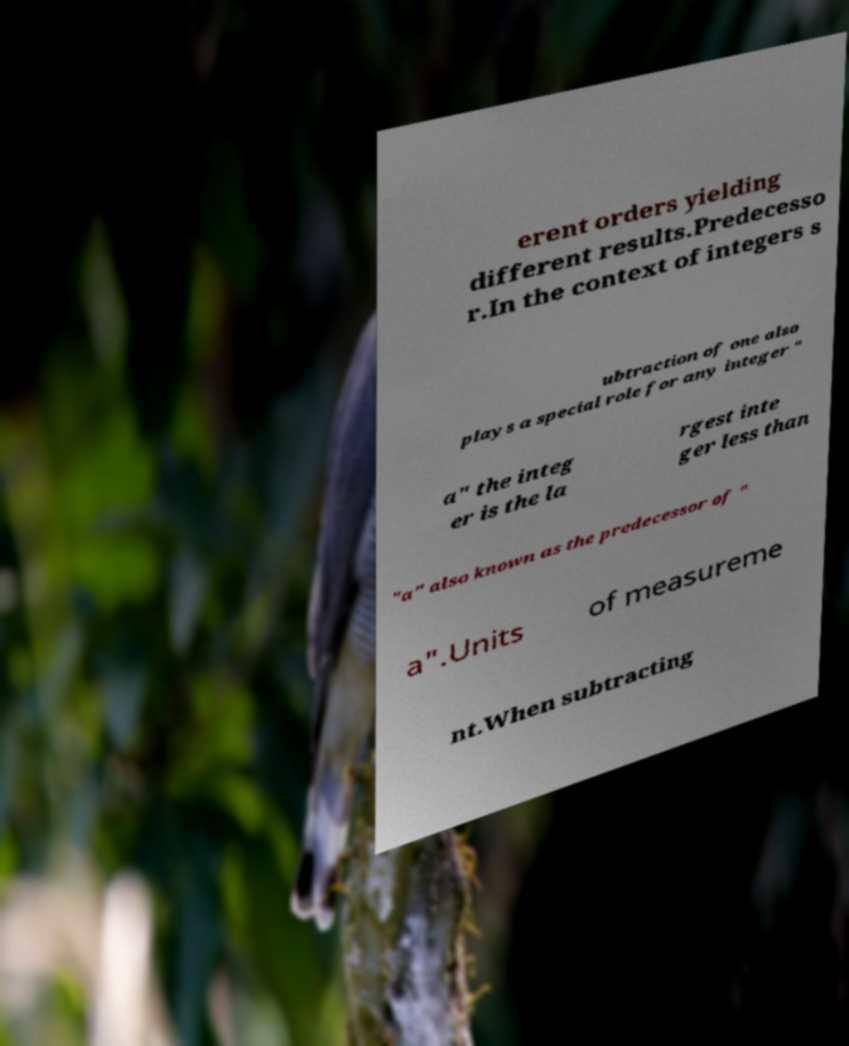Can you accurately transcribe the text from the provided image for me? erent orders yielding different results.Predecesso r.In the context of integers s ubtraction of one also plays a special role for any integer " a" the integ er is the la rgest inte ger less than "a" also known as the predecessor of " a".Units of measureme nt.When subtracting 